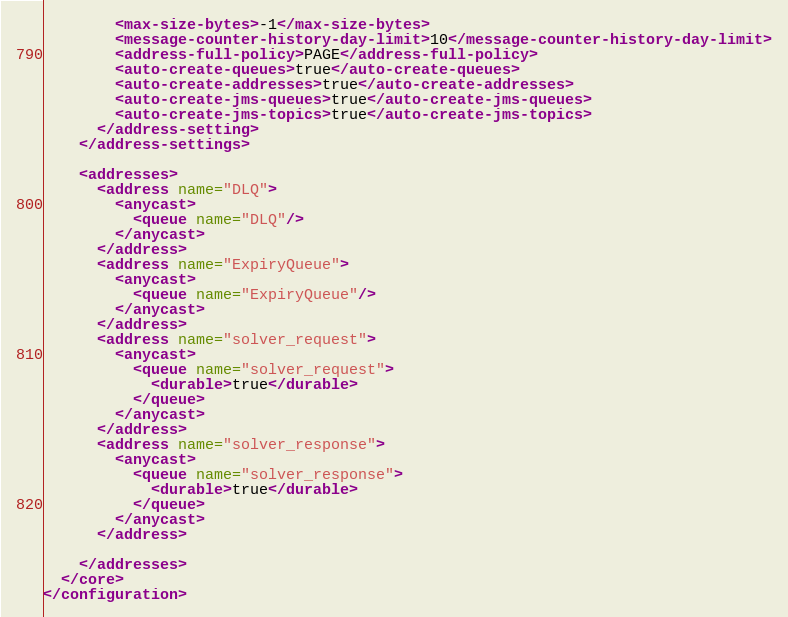<code> <loc_0><loc_0><loc_500><loc_500><_XML_>        <max-size-bytes>-1</max-size-bytes>
        <message-counter-history-day-limit>10</message-counter-history-day-limit>
        <address-full-policy>PAGE</address-full-policy>
        <auto-create-queues>true</auto-create-queues>
        <auto-create-addresses>true</auto-create-addresses>
        <auto-create-jms-queues>true</auto-create-jms-queues>
        <auto-create-jms-topics>true</auto-create-jms-topics>
      </address-setting>
    </address-settings>

    <addresses>
      <address name="DLQ">
        <anycast>
          <queue name="DLQ"/>
        </anycast>
      </address>
      <address name="ExpiryQueue">
        <anycast>
          <queue name="ExpiryQueue"/>
        </anycast>
      </address>
      <address name="solver_request">
        <anycast>
          <queue name="solver_request">
            <durable>true</durable>
          </queue>
        </anycast>
      </address>
      <address name="solver_response">
        <anycast>
          <queue name="solver_response">
            <durable>true</durable>
          </queue>
        </anycast>
      </address>

    </addresses>
  </core>
</configuration>
</code> 